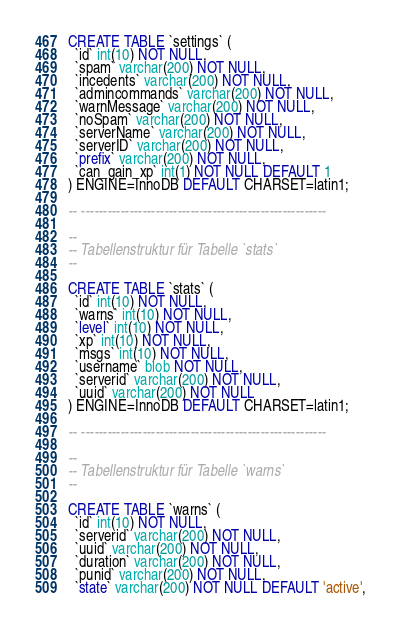<code> <loc_0><loc_0><loc_500><loc_500><_SQL_>
CREATE TABLE `settings` (
  `id` int(10) NOT NULL,
  `spam` varchar(200) NOT NULL,
  `incedents` varchar(200) NOT NULL,
  `admincommands` varchar(200) NOT NULL,
  `warnMessage` varchar(200) NOT NULL,
  `noSpam` varchar(200) NOT NULL,
  `serverName` varchar(200) NOT NULL,
  `serverID` varchar(200) NOT NULL,
  `prefix` varchar(200) NOT NULL,
  `can_gain_xp` int(1) NOT NULL DEFAULT 1
) ENGINE=InnoDB DEFAULT CHARSET=latin1;

-- --------------------------------------------------------

--
-- Tabellenstruktur für Tabelle `stats`
--

CREATE TABLE `stats` (
  `id` int(10) NOT NULL,
  `warns` int(10) NOT NULL,
  `level` int(10) NOT NULL,
  `xp` int(10) NOT NULL,
  `msgs` int(10) NOT NULL,
  `username` blob NOT NULL,
  `serverid` varchar(200) NOT NULL,
  `uuid` varchar(200) NOT NULL
) ENGINE=InnoDB DEFAULT CHARSET=latin1;

-- --------------------------------------------------------

--
-- Tabellenstruktur für Tabelle `warns`
--

CREATE TABLE `warns` (
  `id` int(10) NOT NULL,
  `serverid` varchar(200) NOT NULL,
  `uuid` varchar(200) NOT NULL,
  `duration` varchar(200) NOT NULL,
  `punid` varchar(200) NOT NULL,
  `state` varchar(200) NOT NULL DEFAULT 'active',</code> 